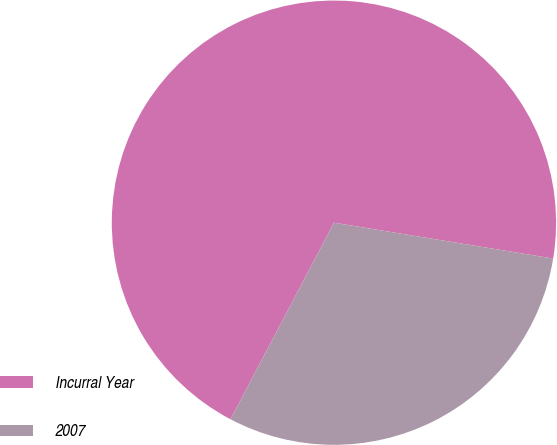<chart> <loc_0><loc_0><loc_500><loc_500><pie_chart><fcel>Incurral Year<fcel>2007<nl><fcel>69.87%<fcel>30.13%<nl></chart> 